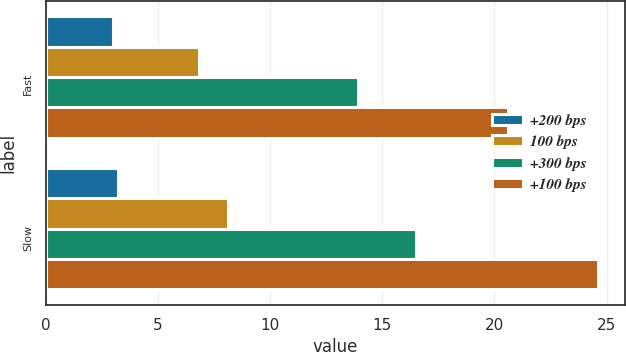Convert chart. <chart><loc_0><loc_0><loc_500><loc_500><stacked_bar_chart><ecel><fcel>Fast<fcel>Slow<nl><fcel>+200 bps<fcel>3<fcel>3.2<nl><fcel>100 bps<fcel>6.8<fcel>8.1<nl><fcel>+300 bps<fcel>13.9<fcel>16.5<nl><fcel>+100 bps<fcel>20.6<fcel>24.6<nl></chart> 